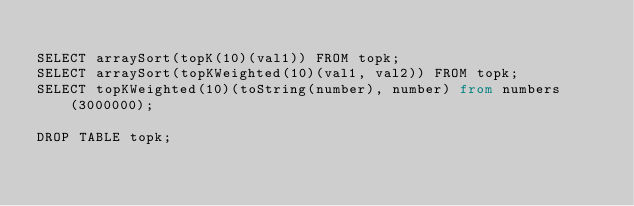<code> <loc_0><loc_0><loc_500><loc_500><_SQL_>
SELECT arraySort(topK(10)(val1)) FROM topk;
SELECT arraySort(topKWeighted(10)(val1, val2)) FROM topk;
SELECT topKWeighted(10)(toString(number), number) from numbers(3000000);

DROP TABLE topk;
</code> 